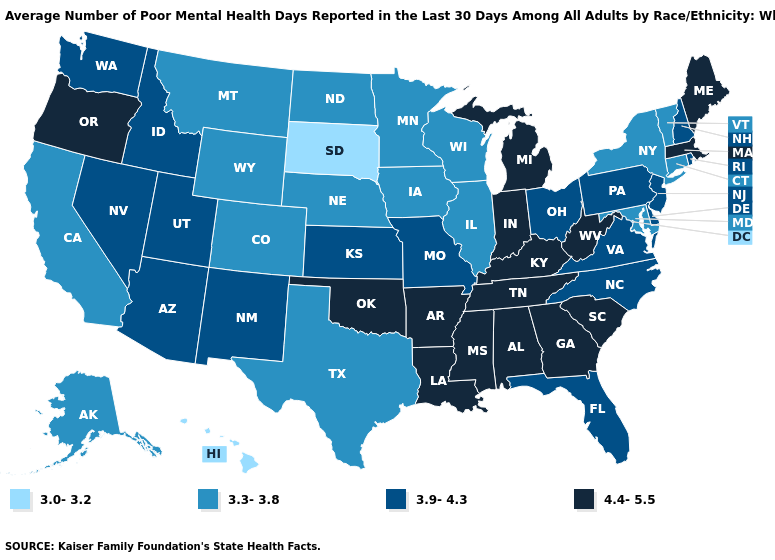What is the value of Montana?
Be succinct. 3.3-3.8. Name the states that have a value in the range 3.0-3.2?
Concise answer only. Hawaii, South Dakota. Does Hawaii have a lower value than South Dakota?
Be succinct. No. Does New Mexico have the same value as Pennsylvania?
Quick response, please. Yes. Among the states that border Colorado , which have the lowest value?
Concise answer only. Nebraska, Wyoming. How many symbols are there in the legend?
Give a very brief answer. 4. What is the value of South Dakota?
Write a very short answer. 3.0-3.2. What is the highest value in the USA?
Give a very brief answer. 4.4-5.5. Does the map have missing data?
Write a very short answer. No. Does North Carolina have the same value as Kentucky?
Quick response, please. No. What is the value of Missouri?
Write a very short answer. 3.9-4.3. Does the map have missing data?
Give a very brief answer. No. What is the highest value in states that border Pennsylvania?
Concise answer only. 4.4-5.5. Does Arkansas have the highest value in the USA?
Short answer required. Yes. 